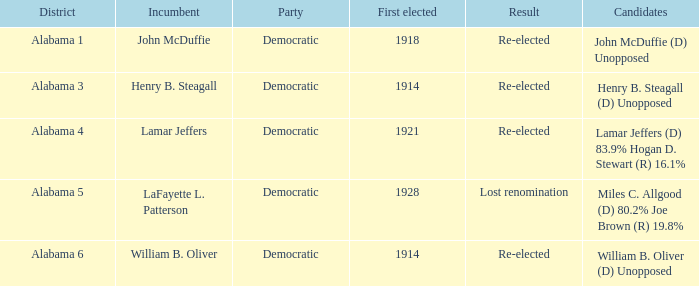How many in total were elected initially in lost renomination? 1.0. 